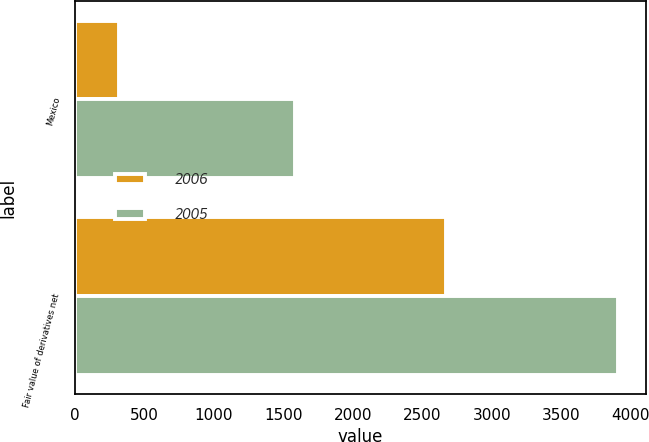Convert chart to OTSL. <chart><loc_0><loc_0><loc_500><loc_500><stacked_bar_chart><ecel><fcel>Mexico<fcel>Fair value of derivatives net<nl><fcel>2006<fcel>316<fcel>2670<nl><fcel>2005<fcel>1586<fcel>3910<nl></chart> 